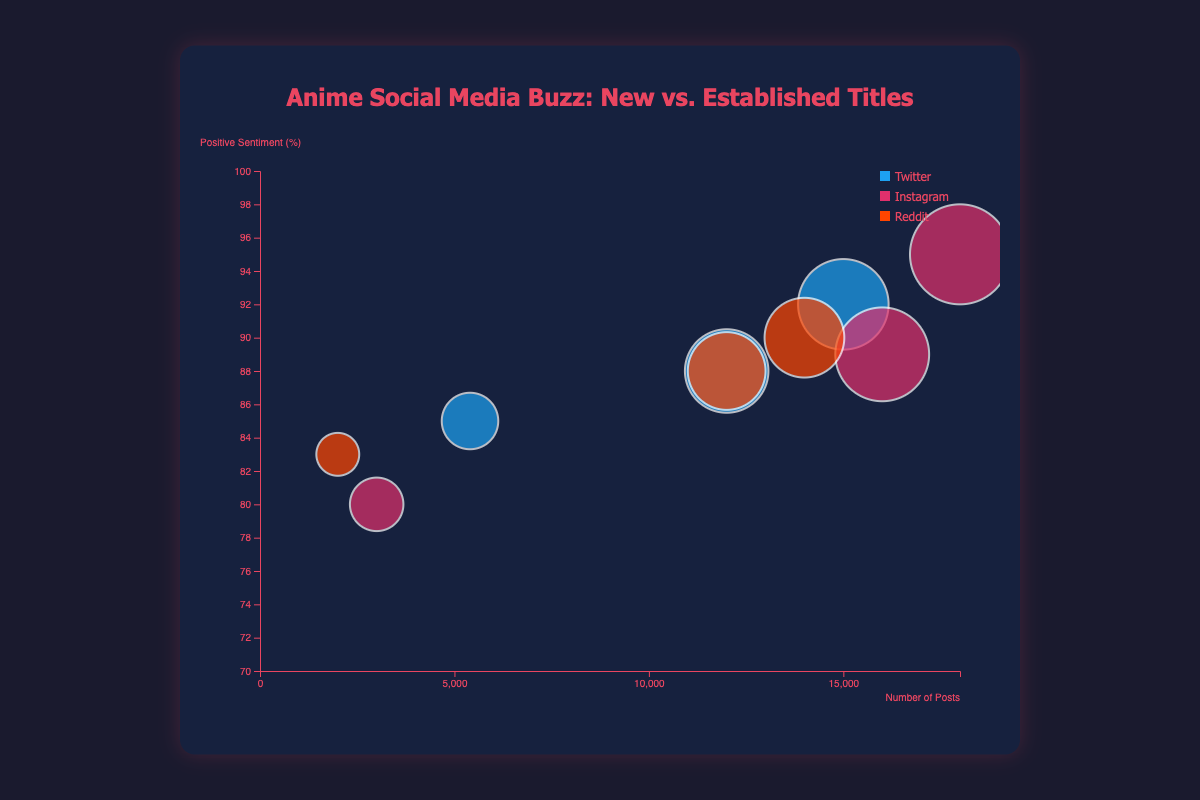How many different social media platforms are represented in the bubble chart? The legend in the chart indicates three different colors, each representing a different platform. There are Twitter, Instagram, and Reddit.
Answer: 3 Which anime title has the highest number of posts on Instagram? The bubble farthest right on the horizontal axis labeled "Number of Posts" within the Instagram color indicates 18,000 posts for "Attack on Titan".
Answer: Attack on Titan What is the positive sentiment percentage for "Doomsday With My Dog" on Twitter? Locate the bubble corresponding to "Doomsday With My Dog" within the Twitter color. The bubble is positioned at about 85% on the vertical axis labeled "Positive Sentiment (%)".
Answer: 85% Which platform has the highest average engagements per post for "Doomsday With My Dog"? Compare the sizes of the three "Doomsday With My Dog" bubbles. The largest bubble, indicating the highest average engagements, is on Twitter with an engagement of 400.
Answer: Twitter Out of all the titles shown, which one has the highest positive sentiment percentage and on which platform? According to the placement of bubbles on the vertical axis for "Positive Sentiment (%)", "Attack on Titan" on Instagram has the highest sentiment at 95%.
Answer: Attack on Titan on Instagram How does the average engagement per post for "Demon Slayer" compare to "Jujutsu Kaisen" on Twitter? Observe the sizes of the two bubbles in the Twitter color. "Demon Slayer" has a larger bubble (1200 engagements) compared to "Jujutsu Kaisen" (1000 engagements).
Answer: Demon Slayer has higher average engagement Which anime has the bubble with the smallest radius on Reddit and what is its average engagement per post? The smallest bubble within the Reddit color corresponds to "Doomsday With My Dog" with an average engagement of 200.
Answer: Doomsday With My Dog, 200 What is the sum of the positive sentiment percentages for "Doomsday With My Dog" across all platforms? Add the positive sentiment percentages for "Doomsday With My Dog" across Twitter, Instagram, and Reddit (85% + 80% + 83%). 85 + 80 + 83 = 248%.
Answer: 248% Compare the total number of posts for "Chainsaw Man" and "One Piece" on Reddit. Which is more? Observe the horizontal positions of the bubbles within the Reddit color. "One Piece" has 14,000 posts which is more than "Chainsaw Man" with 12,000 posts.
Answer: One Piece Which anime title announced in 2023 has the highest average engagement per post? Among the anime titles announced in 2023, "Doomsday With My Dog" appears thrice. Compare the average engagements of the bubbles in all platforms and identify Twitter with 400.
Answer: Doomsday With My Dog on Twitter 